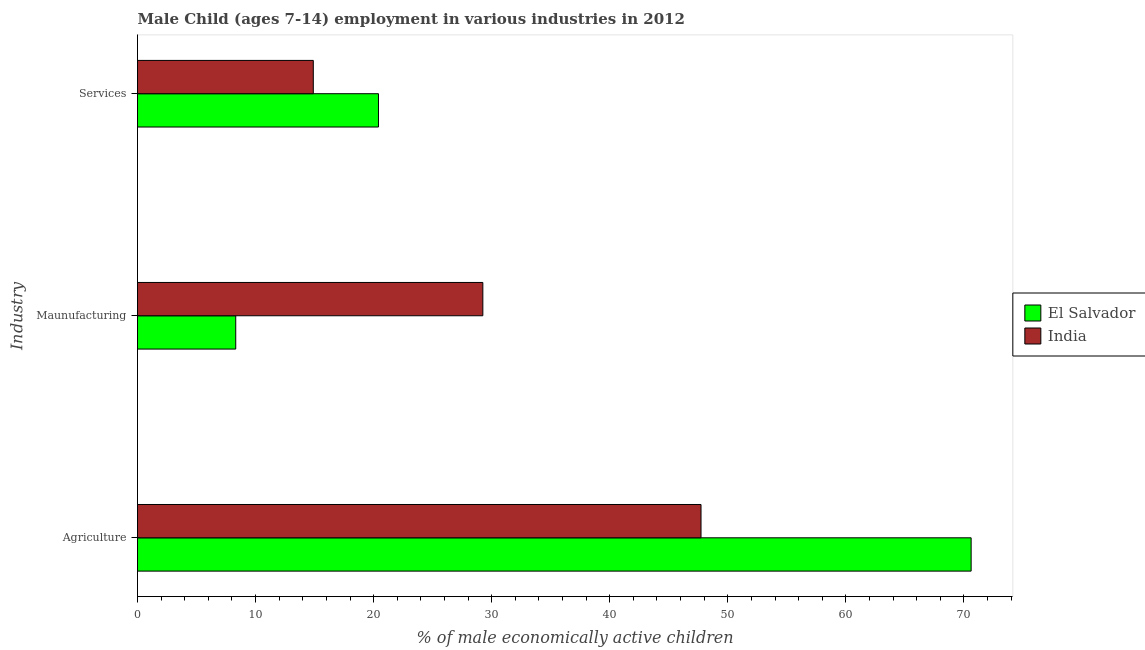How many groups of bars are there?
Give a very brief answer. 3. Are the number of bars per tick equal to the number of legend labels?
Keep it short and to the point. Yes. Are the number of bars on each tick of the Y-axis equal?
Keep it short and to the point. Yes. What is the label of the 2nd group of bars from the top?
Provide a succinct answer. Maunufacturing. What is the percentage of economically active children in manufacturing in India?
Provide a succinct answer. 29.25. Across all countries, what is the maximum percentage of economically active children in manufacturing?
Provide a succinct answer. 29.25. Across all countries, what is the minimum percentage of economically active children in agriculture?
Offer a very short reply. 47.73. In which country was the percentage of economically active children in manufacturing maximum?
Provide a succinct answer. India. In which country was the percentage of economically active children in manufacturing minimum?
Ensure brevity in your answer.  El Salvador. What is the total percentage of economically active children in agriculture in the graph?
Make the answer very short. 118.34. What is the difference between the percentage of economically active children in manufacturing in El Salvador and that in India?
Your answer should be very brief. -20.93. What is the difference between the percentage of economically active children in manufacturing in El Salvador and the percentage of economically active children in agriculture in India?
Provide a succinct answer. -39.41. What is the average percentage of economically active children in agriculture per country?
Your answer should be very brief. 59.17. What is the difference between the percentage of economically active children in manufacturing and percentage of economically active children in services in India?
Keep it short and to the point. 14.36. In how many countries, is the percentage of economically active children in agriculture greater than 10 %?
Your answer should be compact. 2. What is the ratio of the percentage of economically active children in manufacturing in El Salvador to that in India?
Provide a short and direct response. 0.28. Is the percentage of economically active children in services in El Salvador less than that in India?
Give a very brief answer. No. What is the difference between the highest and the second highest percentage of economically active children in services?
Your answer should be very brief. 5.52. What is the difference between the highest and the lowest percentage of economically active children in services?
Ensure brevity in your answer.  5.52. In how many countries, is the percentage of economically active children in services greater than the average percentage of economically active children in services taken over all countries?
Make the answer very short. 1. Is the sum of the percentage of economically active children in manufacturing in India and El Salvador greater than the maximum percentage of economically active children in services across all countries?
Offer a terse response. Yes. What does the 2nd bar from the top in Maunufacturing represents?
Your answer should be very brief. El Salvador. What does the 1st bar from the bottom in Maunufacturing represents?
Give a very brief answer. El Salvador. How many bars are there?
Make the answer very short. 6. Are all the bars in the graph horizontal?
Ensure brevity in your answer.  Yes. How many countries are there in the graph?
Give a very brief answer. 2. How are the legend labels stacked?
Provide a succinct answer. Vertical. What is the title of the graph?
Provide a short and direct response. Male Child (ages 7-14) employment in various industries in 2012. Does "Isle of Man" appear as one of the legend labels in the graph?
Provide a short and direct response. No. What is the label or title of the X-axis?
Provide a short and direct response. % of male economically active children. What is the label or title of the Y-axis?
Ensure brevity in your answer.  Industry. What is the % of male economically active children of El Salvador in Agriculture?
Ensure brevity in your answer.  70.61. What is the % of male economically active children in India in Agriculture?
Your answer should be compact. 47.73. What is the % of male economically active children of El Salvador in Maunufacturing?
Provide a short and direct response. 8.32. What is the % of male economically active children in India in Maunufacturing?
Provide a short and direct response. 29.25. What is the % of male economically active children of El Salvador in Services?
Make the answer very short. 20.41. What is the % of male economically active children in India in Services?
Offer a very short reply. 14.89. Across all Industry, what is the maximum % of male economically active children of El Salvador?
Ensure brevity in your answer.  70.61. Across all Industry, what is the maximum % of male economically active children in India?
Your response must be concise. 47.73. Across all Industry, what is the minimum % of male economically active children of El Salvador?
Provide a succinct answer. 8.32. Across all Industry, what is the minimum % of male economically active children in India?
Keep it short and to the point. 14.89. What is the total % of male economically active children in El Salvador in the graph?
Your answer should be compact. 99.34. What is the total % of male economically active children in India in the graph?
Offer a very short reply. 91.87. What is the difference between the % of male economically active children in El Salvador in Agriculture and that in Maunufacturing?
Ensure brevity in your answer.  62.29. What is the difference between the % of male economically active children in India in Agriculture and that in Maunufacturing?
Provide a short and direct response. 18.48. What is the difference between the % of male economically active children in El Salvador in Agriculture and that in Services?
Your response must be concise. 50.2. What is the difference between the % of male economically active children of India in Agriculture and that in Services?
Provide a succinct answer. 32.84. What is the difference between the % of male economically active children of El Salvador in Maunufacturing and that in Services?
Offer a terse response. -12.09. What is the difference between the % of male economically active children in India in Maunufacturing and that in Services?
Ensure brevity in your answer.  14.36. What is the difference between the % of male economically active children in El Salvador in Agriculture and the % of male economically active children in India in Maunufacturing?
Your answer should be compact. 41.36. What is the difference between the % of male economically active children in El Salvador in Agriculture and the % of male economically active children in India in Services?
Provide a short and direct response. 55.72. What is the difference between the % of male economically active children of El Salvador in Maunufacturing and the % of male economically active children of India in Services?
Ensure brevity in your answer.  -6.57. What is the average % of male economically active children in El Salvador per Industry?
Offer a terse response. 33.11. What is the average % of male economically active children in India per Industry?
Keep it short and to the point. 30.62. What is the difference between the % of male economically active children in El Salvador and % of male economically active children in India in Agriculture?
Offer a very short reply. 22.88. What is the difference between the % of male economically active children of El Salvador and % of male economically active children of India in Maunufacturing?
Provide a succinct answer. -20.93. What is the difference between the % of male economically active children in El Salvador and % of male economically active children in India in Services?
Ensure brevity in your answer.  5.52. What is the ratio of the % of male economically active children in El Salvador in Agriculture to that in Maunufacturing?
Give a very brief answer. 8.49. What is the ratio of the % of male economically active children of India in Agriculture to that in Maunufacturing?
Provide a succinct answer. 1.63. What is the ratio of the % of male economically active children of El Salvador in Agriculture to that in Services?
Make the answer very short. 3.46. What is the ratio of the % of male economically active children of India in Agriculture to that in Services?
Provide a succinct answer. 3.21. What is the ratio of the % of male economically active children of El Salvador in Maunufacturing to that in Services?
Offer a terse response. 0.41. What is the ratio of the % of male economically active children of India in Maunufacturing to that in Services?
Ensure brevity in your answer.  1.96. What is the difference between the highest and the second highest % of male economically active children in El Salvador?
Offer a terse response. 50.2. What is the difference between the highest and the second highest % of male economically active children of India?
Your answer should be compact. 18.48. What is the difference between the highest and the lowest % of male economically active children of El Salvador?
Keep it short and to the point. 62.29. What is the difference between the highest and the lowest % of male economically active children in India?
Provide a succinct answer. 32.84. 